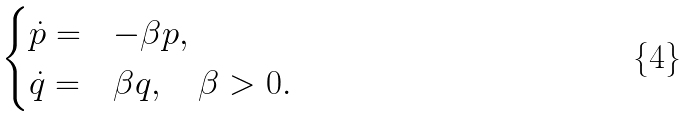Convert formula to latex. <formula><loc_0><loc_0><loc_500><loc_500>\begin{cases} \dot { p } = & - \beta p , \\ \dot { q } = & \beta q , \quad \beta > 0 . \end{cases}</formula> 